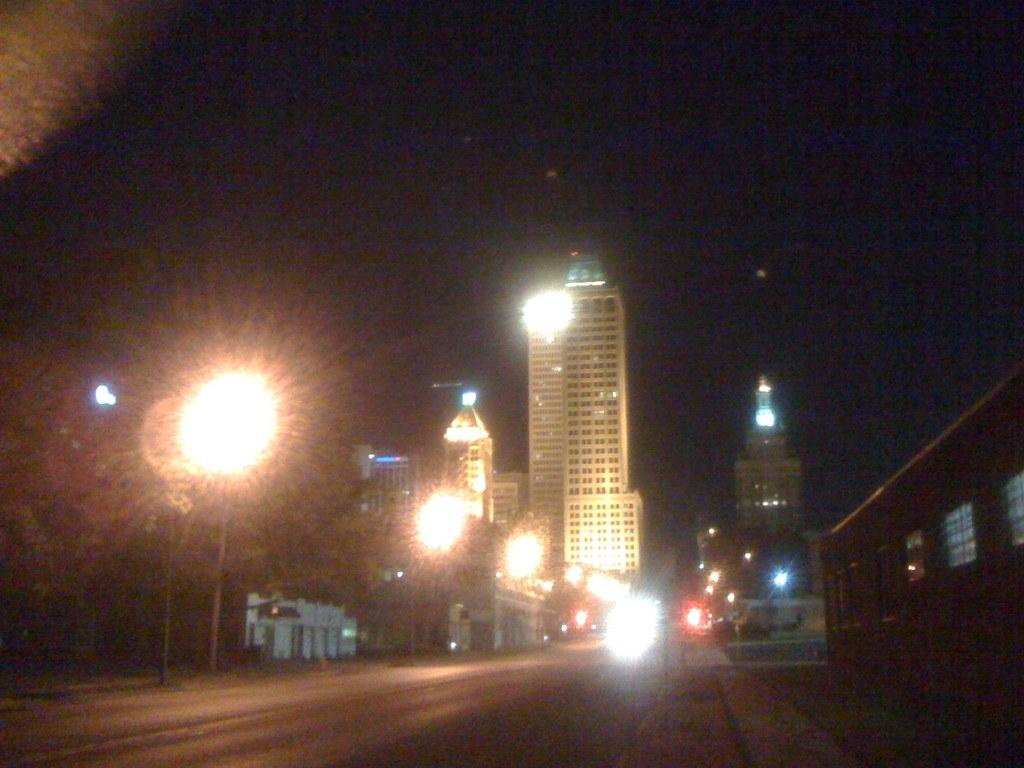What is the main feature of the image? There is a road in the image. What can be seen in the distance behind the road? There are buildings and lights visible in the background of the image. What part of the natural environment is visible in the image? The sky is visible in the background of the image. What type of protest is taking place on the road in the image? There is no protest present in the image; it only features a road, buildings, lights, and the sky. What color is the blood on the road in the image? There is no blood present in the image; it only features a road, buildings, lights, and the sky. 